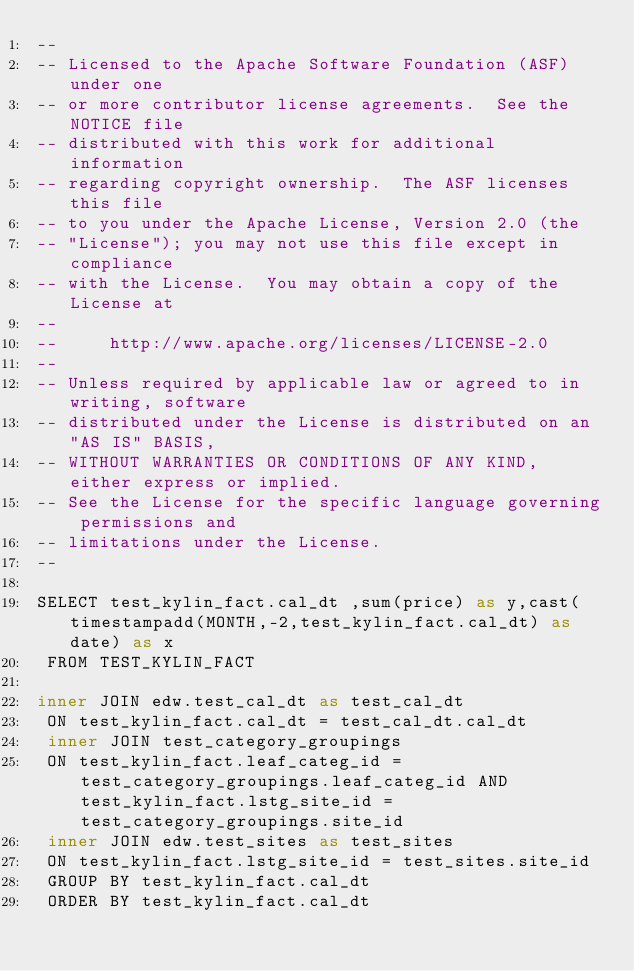<code> <loc_0><loc_0><loc_500><loc_500><_SQL_>--
-- Licensed to the Apache Software Foundation (ASF) under one
-- or more contributor license agreements.  See the NOTICE file
-- distributed with this work for additional information
-- regarding copyright ownership.  The ASF licenses this file
-- to you under the Apache License, Version 2.0 (the
-- "License"); you may not use this file except in compliance
-- with the License.  You may obtain a copy of the License at
--
--     http://www.apache.org/licenses/LICENSE-2.0
--
-- Unless required by applicable law or agreed to in writing, software
-- distributed under the License is distributed on an "AS IS" BASIS,
-- WITHOUT WARRANTIES OR CONDITIONS OF ANY KIND, either express or implied.
-- See the License for the specific language governing permissions and
-- limitations under the License.
--

SELECT test_kylin_fact.cal_dt ,sum(price) as y,cast(timestampadd(MONTH,-2,test_kylin_fact.cal_dt) as date) as x
 FROM TEST_KYLIN_FACT 
 
inner JOIN edw.test_cal_dt as test_cal_dt
 ON test_kylin_fact.cal_dt = test_cal_dt.cal_dt
 inner JOIN test_category_groupings
 ON test_kylin_fact.leaf_categ_id = test_category_groupings.leaf_categ_id AND test_kylin_fact.lstg_site_id = test_category_groupings.site_id
 inner JOIN edw.test_sites as test_sites
 ON test_kylin_fact.lstg_site_id = test_sites.site_id
 GROUP BY test_kylin_fact.cal_dt
 ORDER BY test_kylin_fact.cal_dt</code> 